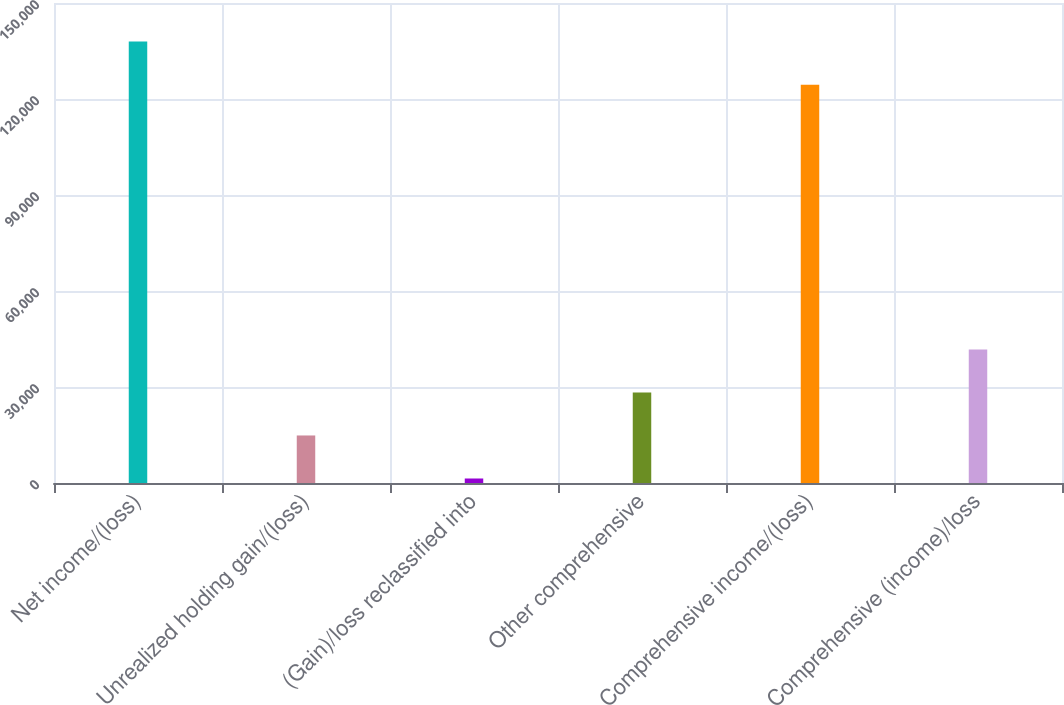Convert chart to OTSL. <chart><loc_0><loc_0><loc_500><loc_500><bar_chart><fcel>Net income/(loss)<fcel>Unrealized holding gain/(loss)<fcel>(Gain)/loss reclassified into<fcel>Other comprehensive<fcel>Comprehensive income/(loss)<fcel>Comprehensive (income)/loss<nl><fcel>137932<fcel>14852.7<fcel>1407<fcel>28298.4<fcel>124486<fcel>41744.1<nl></chart> 